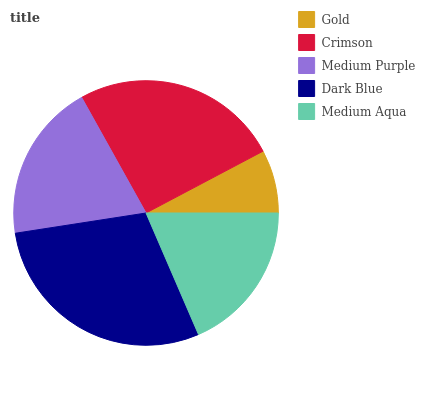Is Gold the minimum?
Answer yes or no. Yes. Is Dark Blue the maximum?
Answer yes or no. Yes. Is Crimson the minimum?
Answer yes or no. No. Is Crimson the maximum?
Answer yes or no. No. Is Crimson greater than Gold?
Answer yes or no. Yes. Is Gold less than Crimson?
Answer yes or no. Yes. Is Gold greater than Crimson?
Answer yes or no. No. Is Crimson less than Gold?
Answer yes or no. No. Is Medium Purple the high median?
Answer yes or no. Yes. Is Medium Purple the low median?
Answer yes or no. Yes. Is Crimson the high median?
Answer yes or no. No. Is Dark Blue the low median?
Answer yes or no. No. 